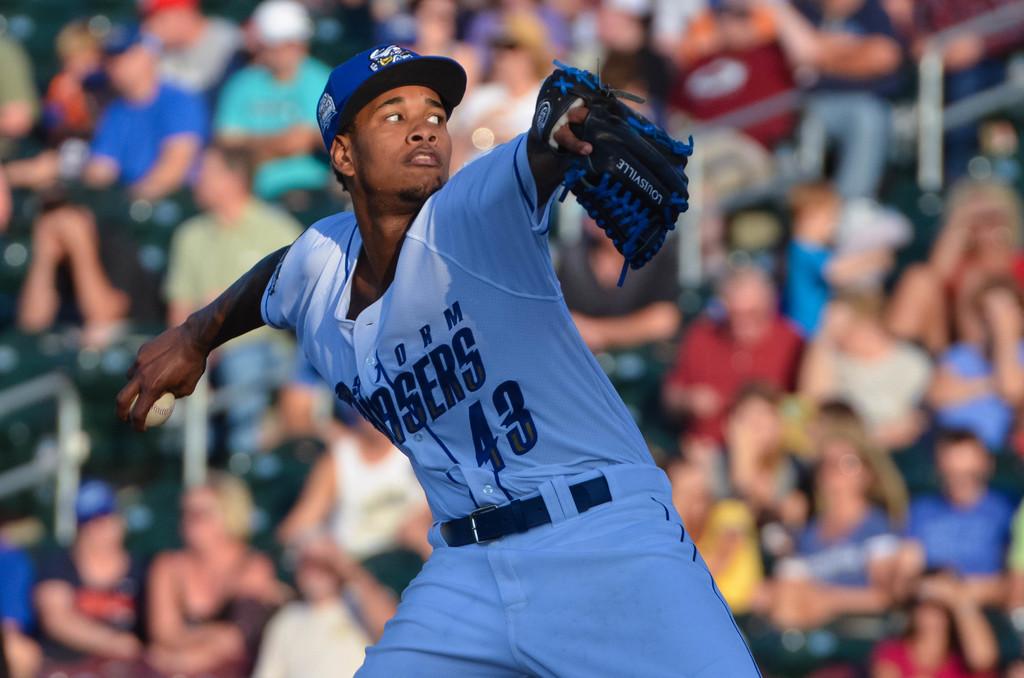What number is the player?
Your answer should be compact. 43. What kind of glove is he using?
Your answer should be very brief. Louisville. 